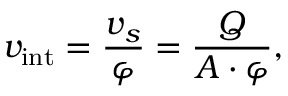<formula> <loc_0><loc_0><loc_500><loc_500>v _ { i n t } = \frac { v _ { s } } { \varphi } = \frac { Q } { A \cdot \varphi } ,</formula> 